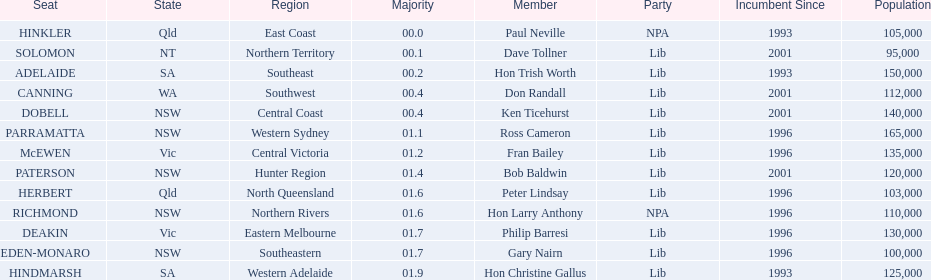What state does hinkler belong too? Qld. What is the majority of difference between sa and qld? 01.9. 